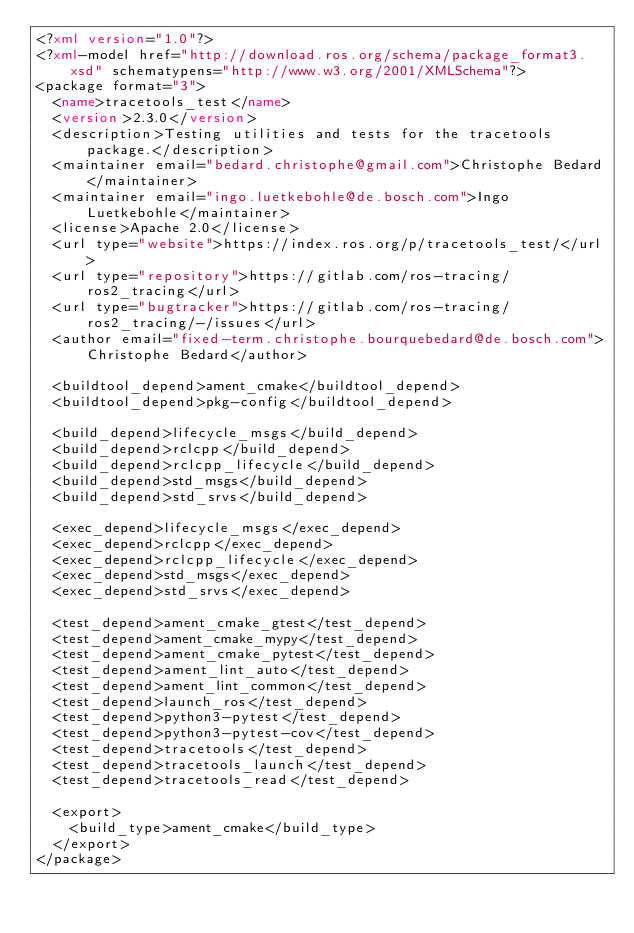Convert code to text. <code><loc_0><loc_0><loc_500><loc_500><_XML_><?xml version="1.0"?>
<?xml-model href="http://download.ros.org/schema/package_format3.xsd" schematypens="http://www.w3.org/2001/XMLSchema"?>
<package format="3">
  <name>tracetools_test</name>
  <version>2.3.0</version>
  <description>Testing utilities and tests for the tracetools package.</description>
  <maintainer email="bedard.christophe@gmail.com">Christophe Bedard</maintainer>
  <maintainer email="ingo.luetkebohle@de.bosch.com">Ingo Luetkebohle</maintainer>
  <license>Apache 2.0</license>
  <url type="website">https://index.ros.org/p/tracetools_test/</url>
  <url type="repository">https://gitlab.com/ros-tracing/ros2_tracing</url>
  <url type="bugtracker">https://gitlab.com/ros-tracing/ros2_tracing/-/issues</url>
  <author email="fixed-term.christophe.bourquebedard@de.bosch.com">Christophe Bedard</author>

  <buildtool_depend>ament_cmake</buildtool_depend>
  <buildtool_depend>pkg-config</buildtool_depend>

  <build_depend>lifecycle_msgs</build_depend>
  <build_depend>rclcpp</build_depend>
  <build_depend>rclcpp_lifecycle</build_depend>
  <build_depend>std_msgs</build_depend>
  <build_depend>std_srvs</build_depend>

  <exec_depend>lifecycle_msgs</exec_depend>
  <exec_depend>rclcpp</exec_depend>
  <exec_depend>rclcpp_lifecycle</exec_depend>
  <exec_depend>std_msgs</exec_depend>
  <exec_depend>std_srvs</exec_depend>

  <test_depend>ament_cmake_gtest</test_depend>
  <test_depend>ament_cmake_mypy</test_depend>
  <test_depend>ament_cmake_pytest</test_depend>
  <test_depend>ament_lint_auto</test_depend>
  <test_depend>ament_lint_common</test_depend>
  <test_depend>launch_ros</test_depend>
  <test_depend>python3-pytest</test_depend>
  <test_depend>python3-pytest-cov</test_depend>
  <test_depend>tracetools</test_depend>
  <test_depend>tracetools_launch</test_depend>
  <test_depend>tracetools_read</test_depend>

  <export>
    <build_type>ament_cmake</build_type>
  </export>
</package>
</code> 